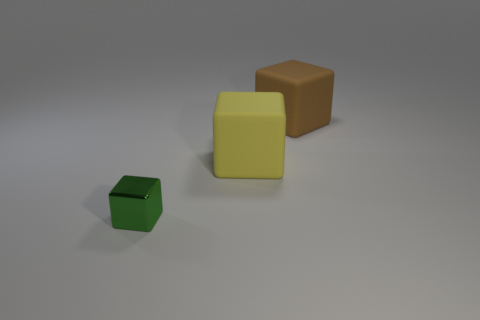Subtract all green blocks. How many blocks are left? 2 Add 1 cyan shiny spheres. How many objects exist? 4 Subtract all yellow blocks. How many blocks are left? 2 Subtract 1 blocks. How many blocks are left? 2 Add 2 small shiny things. How many small shiny things exist? 3 Subtract 0 gray spheres. How many objects are left? 3 Subtract all purple blocks. Subtract all brown spheres. How many blocks are left? 3 Subtract all big rubber blocks. Subtract all big red spheres. How many objects are left? 1 Add 3 small blocks. How many small blocks are left? 4 